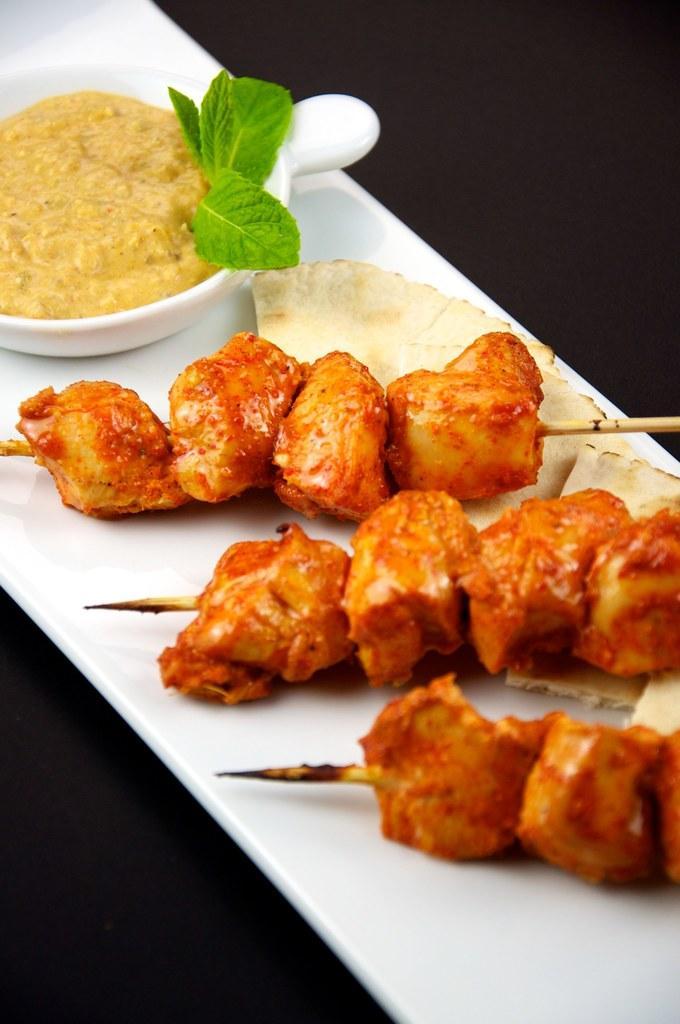Can you describe this image briefly? In the image we can see some food and plate and cup. 